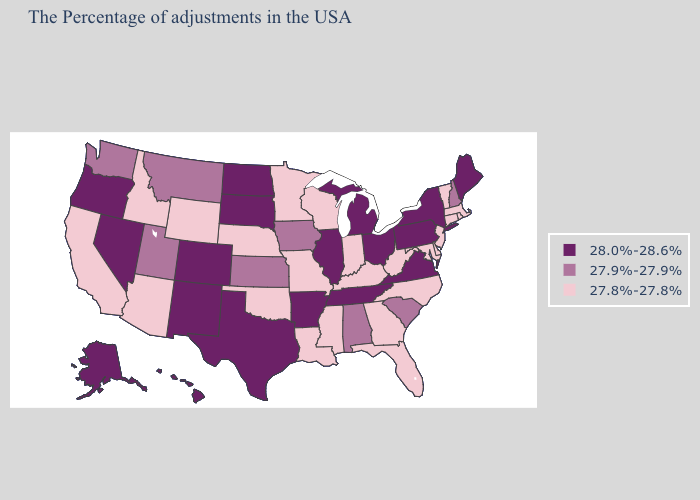Does Missouri have the highest value in the USA?
Keep it brief. No. Does Massachusetts have the same value as Alaska?
Quick response, please. No. Among the states that border Louisiana , which have the highest value?
Give a very brief answer. Arkansas, Texas. Which states have the lowest value in the USA?
Quick response, please. Massachusetts, Rhode Island, Vermont, Connecticut, New Jersey, Delaware, Maryland, North Carolina, West Virginia, Florida, Georgia, Kentucky, Indiana, Wisconsin, Mississippi, Louisiana, Missouri, Minnesota, Nebraska, Oklahoma, Wyoming, Arizona, Idaho, California. What is the highest value in the USA?
Concise answer only. 28.0%-28.6%. Does Ohio have the lowest value in the USA?
Be succinct. No. Name the states that have a value in the range 28.0%-28.6%?
Concise answer only. Maine, New York, Pennsylvania, Virginia, Ohio, Michigan, Tennessee, Illinois, Arkansas, Texas, South Dakota, North Dakota, Colorado, New Mexico, Nevada, Oregon, Alaska, Hawaii. Name the states that have a value in the range 27.9%-27.9%?
Short answer required. New Hampshire, South Carolina, Alabama, Iowa, Kansas, Utah, Montana, Washington. What is the highest value in the USA?
Write a very short answer. 28.0%-28.6%. Does Florida have the lowest value in the USA?
Write a very short answer. Yes. Which states have the lowest value in the USA?
Concise answer only. Massachusetts, Rhode Island, Vermont, Connecticut, New Jersey, Delaware, Maryland, North Carolina, West Virginia, Florida, Georgia, Kentucky, Indiana, Wisconsin, Mississippi, Louisiana, Missouri, Minnesota, Nebraska, Oklahoma, Wyoming, Arizona, Idaho, California. Name the states that have a value in the range 28.0%-28.6%?
Keep it brief. Maine, New York, Pennsylvania, Virginia, Ohio, Michigan, Tennessee, Illinois, Arkansas, Texas, South Dakota, North Dakota, Colorado, New Mexico, Nevada, Oregon, Alaska, Hawaii. Does Massachusetts have a lower value than California?
Short answer required. No. Does South Dakota have the same value as Utah?
Give a very brief answer. No. Does New Mexico have the lowest value in the USA?
Give a very brief answer. No. 